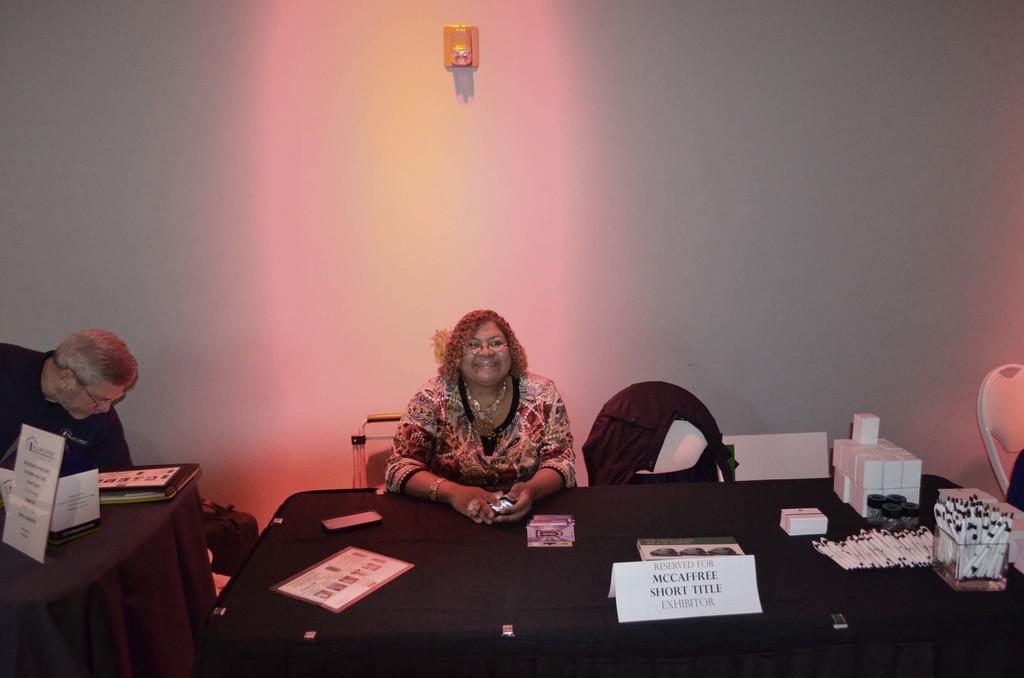Describe this image in one or two sentences. In this image we can see a woman sitting on the chair around the table. There are pens, name board and mobile phone on the table. In the background we can see a wall. 